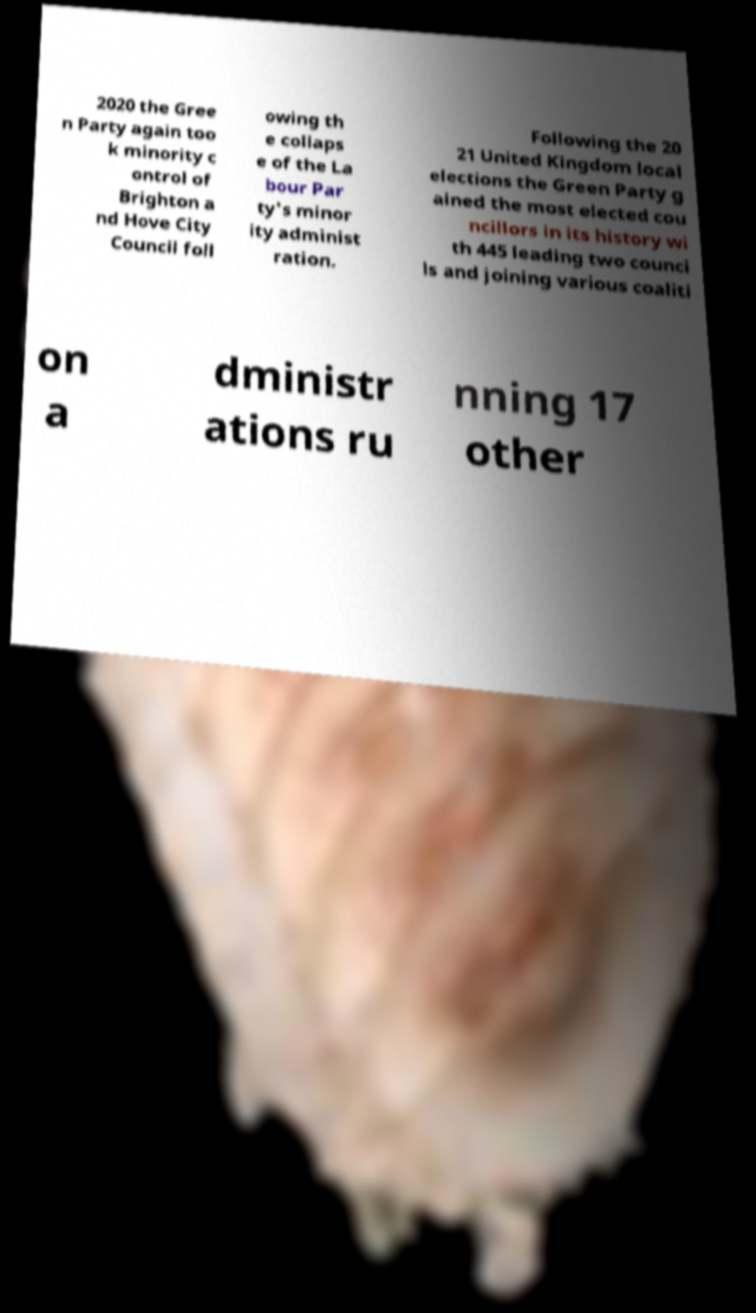Could you assist in decoding the text presented in this image and type it out clearly? 2020 the Gree n Party again too k minority c ontrol of Brighton a nd Hove City Council foll owing th e collaps e of the La bour Par ty's minor ity administ ration. Following the 20 21 United Kingdom local elections the Green Party g ained the most elected cou ncillors in its history wi th 445 leading two counci ls and joining various coaliti on a dministr ations ru nning 17 other 